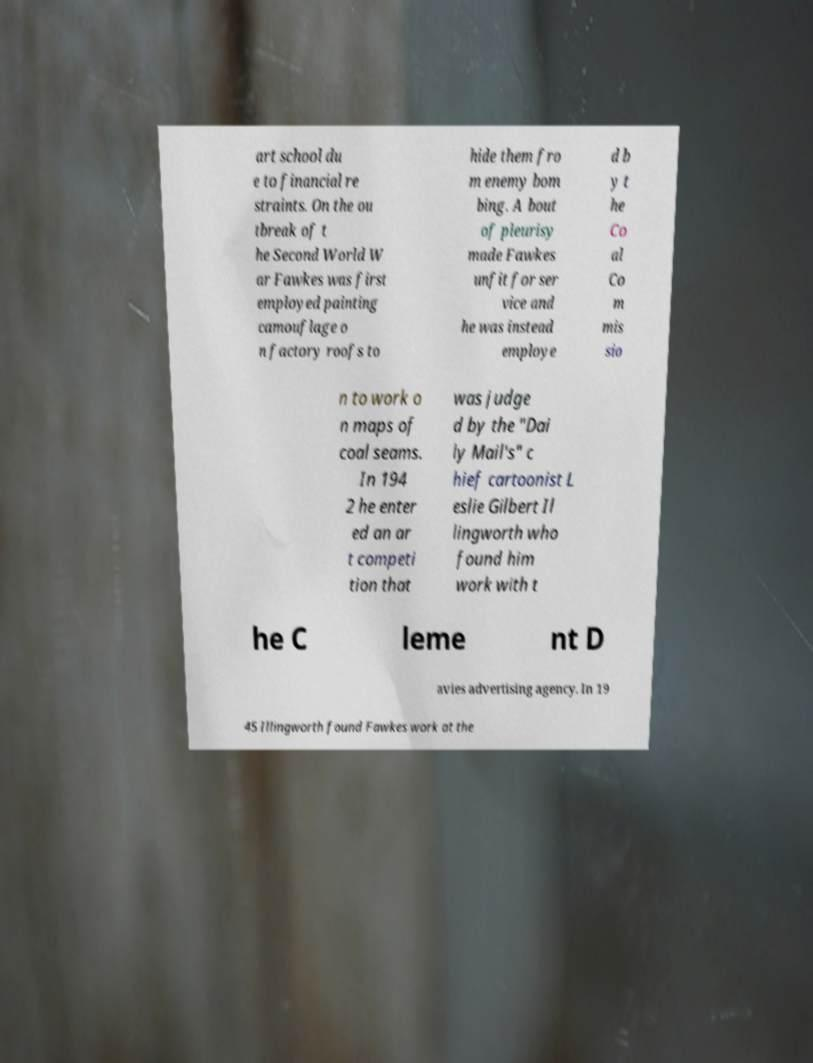Can you read and provide the text displayed in the image?This photo seems to have some interesting text. Can you extract and type it out for me? art school du e to financial re straints. On the ou tbreak of t he Second World W ar Fawkes was first employed painting camouflage o n factory roofs to hide them fro m enemy bom bing. A bout of pleurisy made Fawkes unfit for ser vice and he was instead employe d b y t he Co al Co m mis sio n to work o n maps of coal seams. In 194 2 he enter ed an ar t competi tion that was judge d by the "Dai ly Mail's" c hief cartoonist L eslie Gilbert Il lingworth who found him work with t he C leme nt D avies advertising agency. In 19 45 Illingworth found Fawkes work at the 